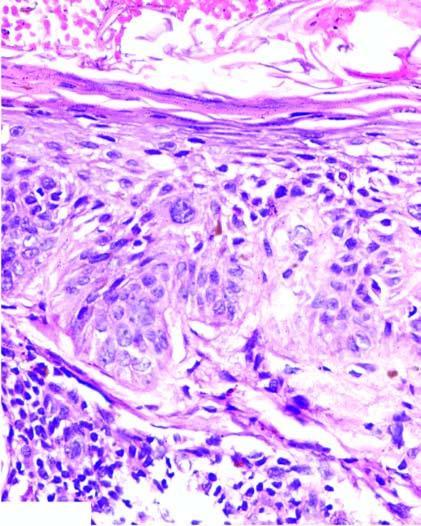s the basement membrane not breached?
Answer the question using a single word or phrase. Yes 